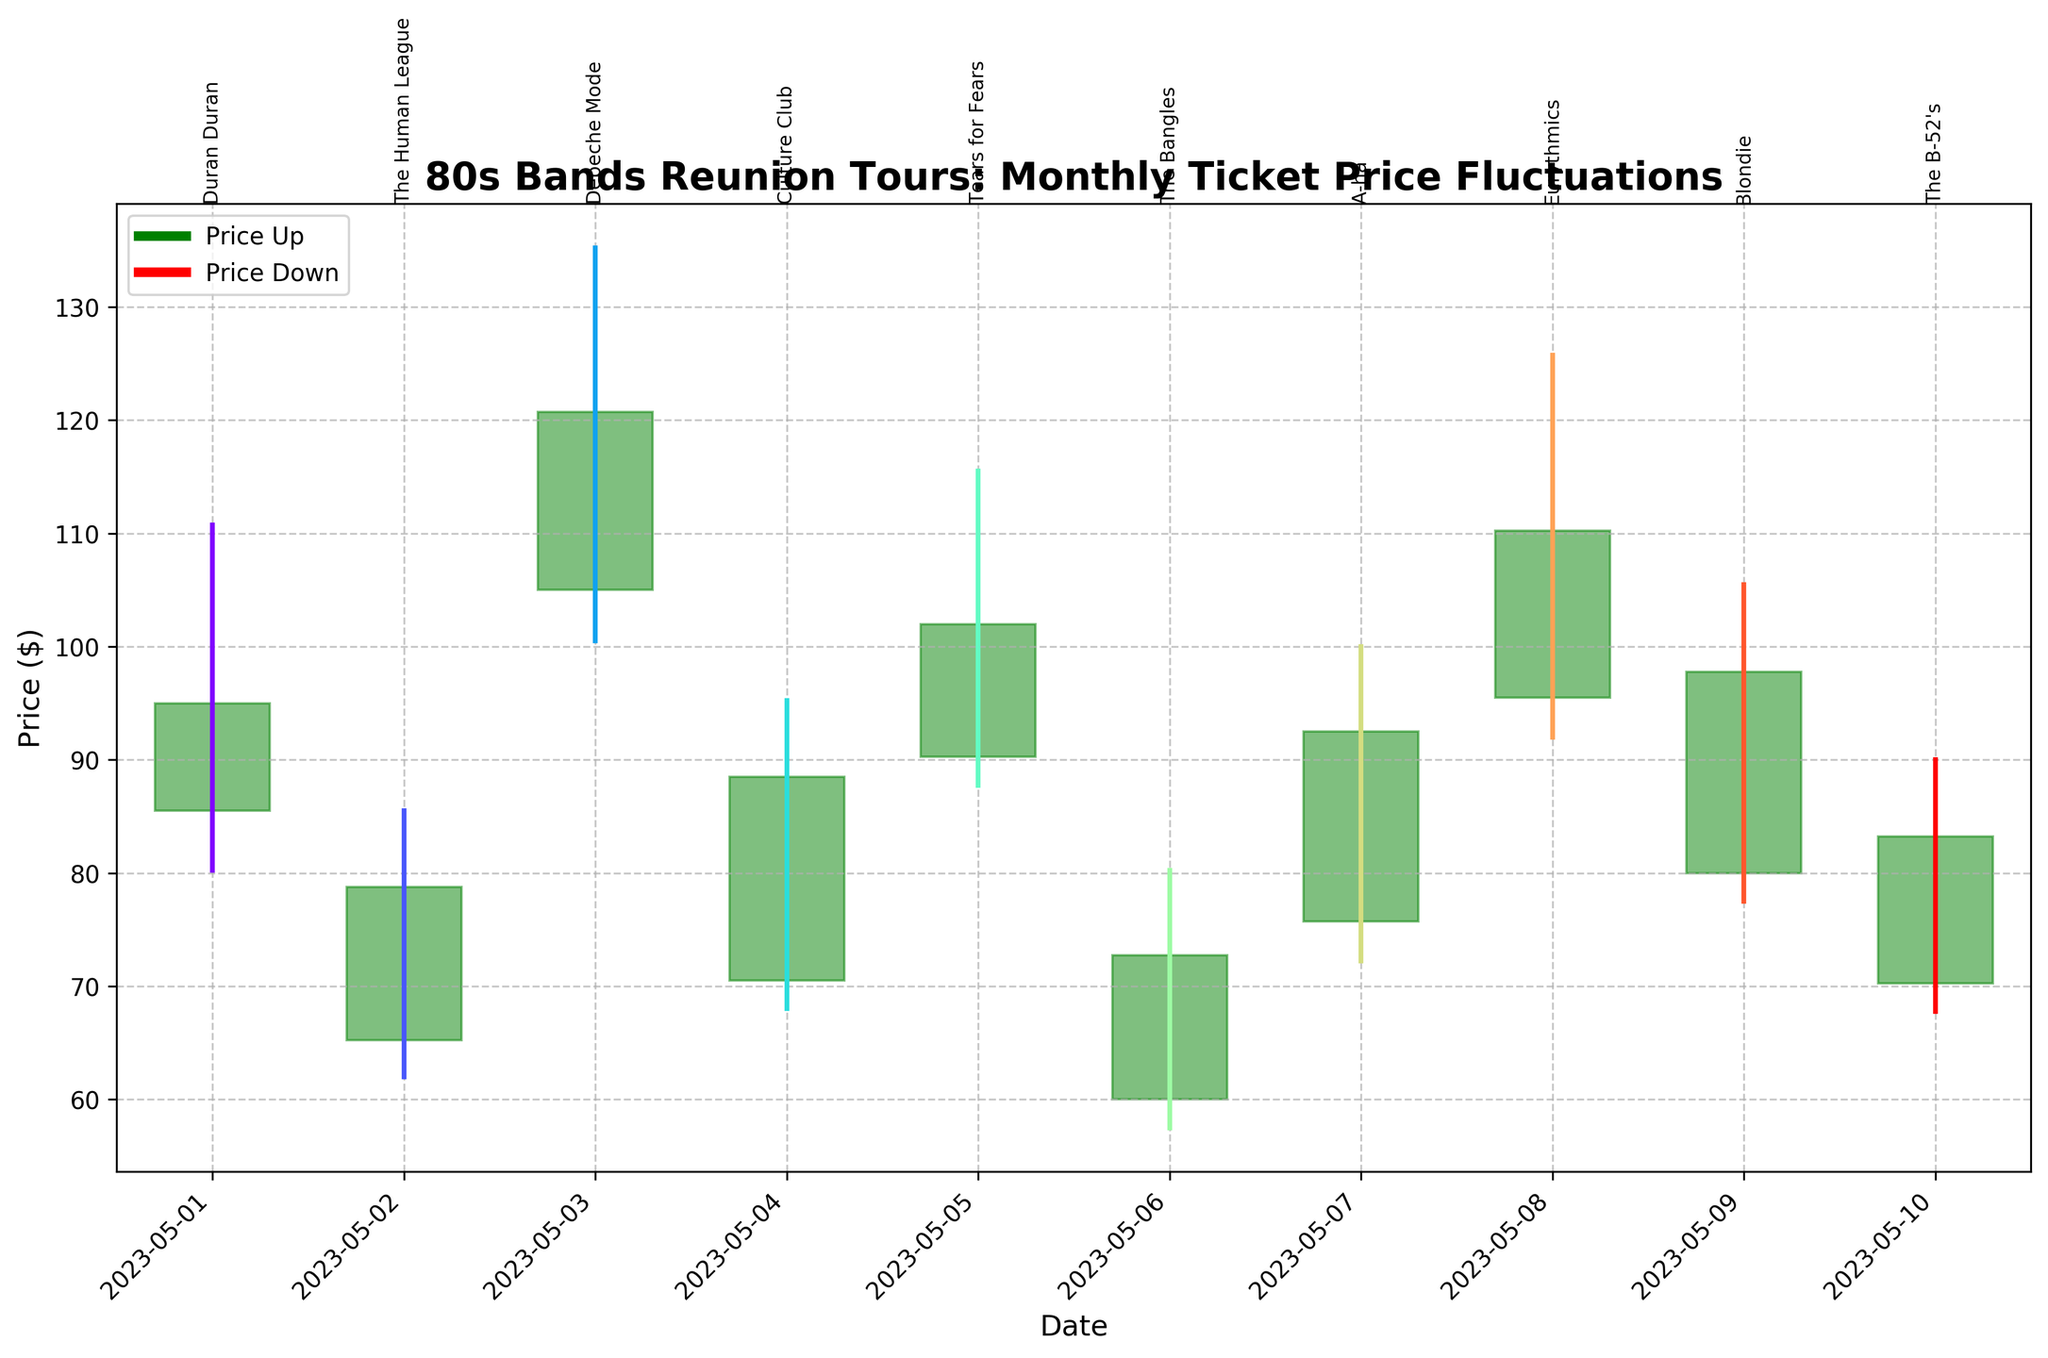What is the title of the plot? The title is displayed at the top of the plot, indicating what the chart is about.
Answer: 80s Bands Reunion Tours: Monthly Ticket Price Fluctuations How many bands' ticket price data are displayed in the chart? By counting the number of date-band annotations along the plot's x-axis, we can determine the total number of bands.
Answer: 10 Which band's ticket prices had the highest peak in May 2023? By comparing the highest values in the High (H) column for each band, we find the peak value. Depeche Mode has the highest peak at 135.25.
Answer: Depeche Mode Which band's ticket prices increased the most from opening to closing price? Calculate the difference between the Open and Close prices for each band and identify the maximum difference. Depeche Mode has the largest increase (120.75 - 105.00 = 15.75).
Answer: Depeche Mode Which band's ticket prices decreased from opening to closing price? Identify bands where the Open price is higher than the Close price. Duran Duran and The Bangles have decreasing prices.
Answer: Duran Duran, The Bangles What is the average closing price of all bands for May 2023? Add up the closing prices of all bands and divide by the number of bands. (95.00 + 78.75 + 120.75 + 88.50 + 102.00 + 72.75 + 92.50 + 110.25 + 97.75 + 83.25) / 10 = 94.25
Answer: 94.25 Which band's ticket prices had the largest range within one month? Calculate the range (High - Low) for each band and find the maximum range. Depeche Mode has the largest range (135.25 - 100.50 = 34.75).
Answer: Depeche Mode On which date did Tears for Fears experience their highest ticket price? Refer to the High column for Tears for Fears and the corresponding date. The highest price for them was on May 5th, at 115.50.
Answer: May 5th What is the smallest opening price for the bands in May 2023? Compare the Open prices for all bands and find the lowest value. The Bangles have the smallest opening price at 60.00.
Answer: 60.00 Which band's ticket prices have a candlestick body shown in green in May 2023? The green candlestick bodies indicate bands where the closing price is higher than the opening price. The bands are The Human League, Depeche Mode, Culture Club, Tears for Fears, A-ha, Eurythmics, and Blondie.
Answer: The Human League, Depeche Mode, Culture Club, Tears for Fears, A-ha, Eurythmics, Blondie 